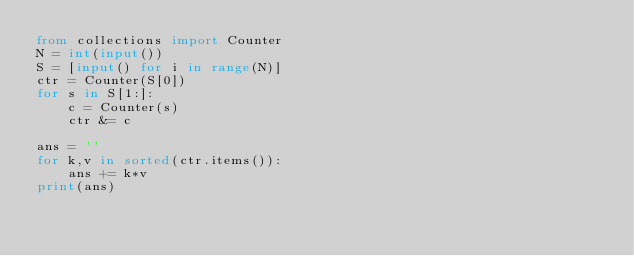Convert code to text. <code><loc_0><loc_0><loc_500><loc_500><_Python_>from collections import Counter
N = int(input())
S = [input() for i in range(N)]
ctr = Counter(S[0])
for s in S[1:]:
    c = Counter(s)
    ctr &= c

ans = ''
for k,v in sorted(ctr.items()):
    ans += k*v
print(ans)</code> 